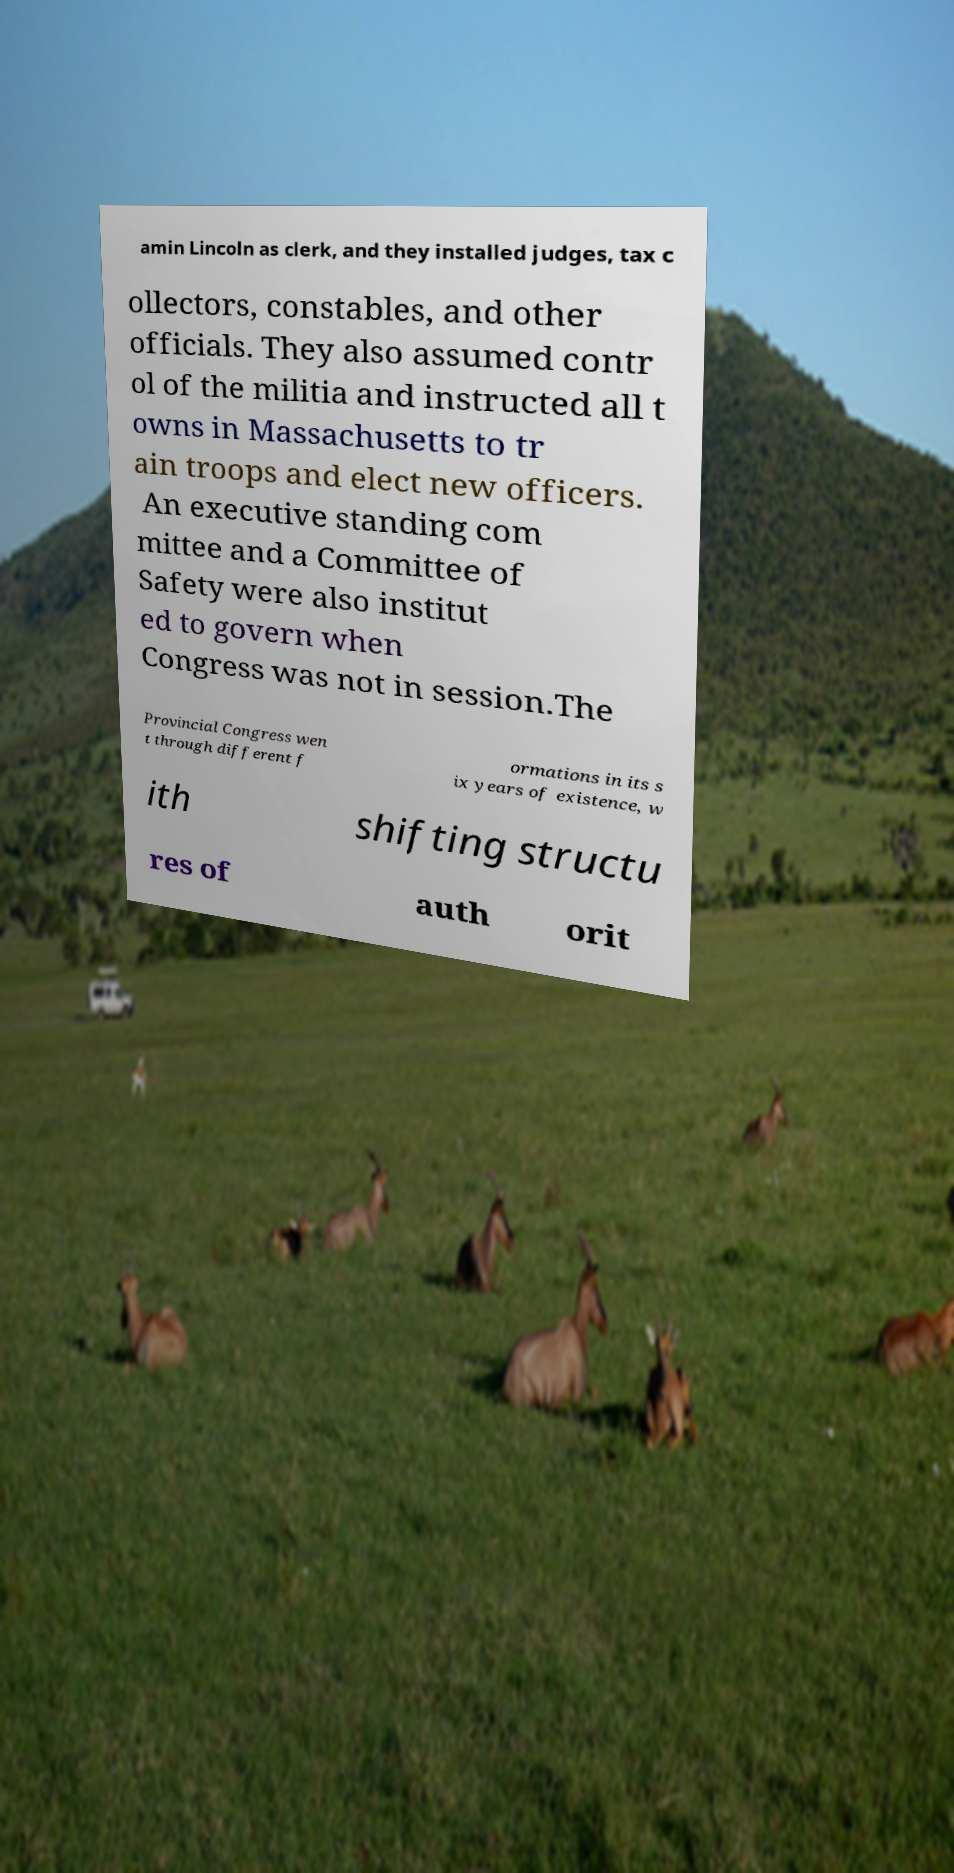For documentation purposes, I need the text within this image transcribed. Could you provide that? amin Lincoln as clerk, and they installed judges, tax c ollectors, constables, and other officials. They also assumed contr ol of the militia and instructed all t owns in Massachusetts to tr ain troops and elect new officers. An executive standing com mittee and a Committee of Safety were also institut ed to govern when Congress was not in session.The Provincial Congress wen t through different f ormations in its s ix years of existence, w ith shifting structu res of auth orit 